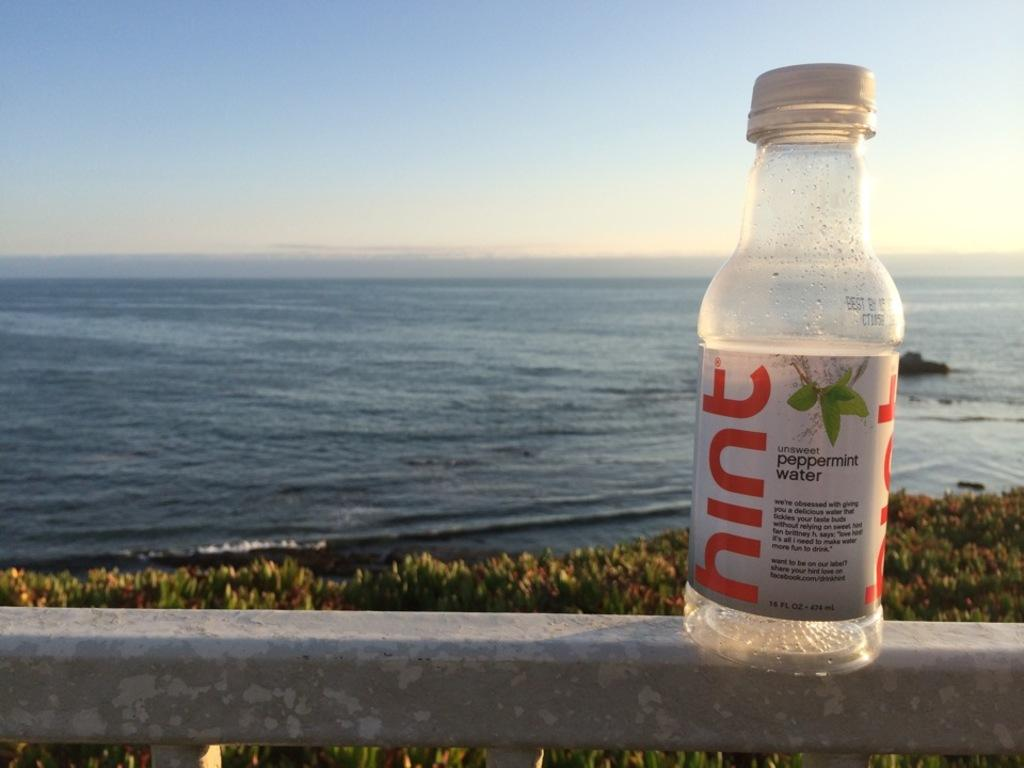<image>
Share a concise interpretation of the image provided. An empty bottle of peppermint water sits on a railing in front of the shoreline. 